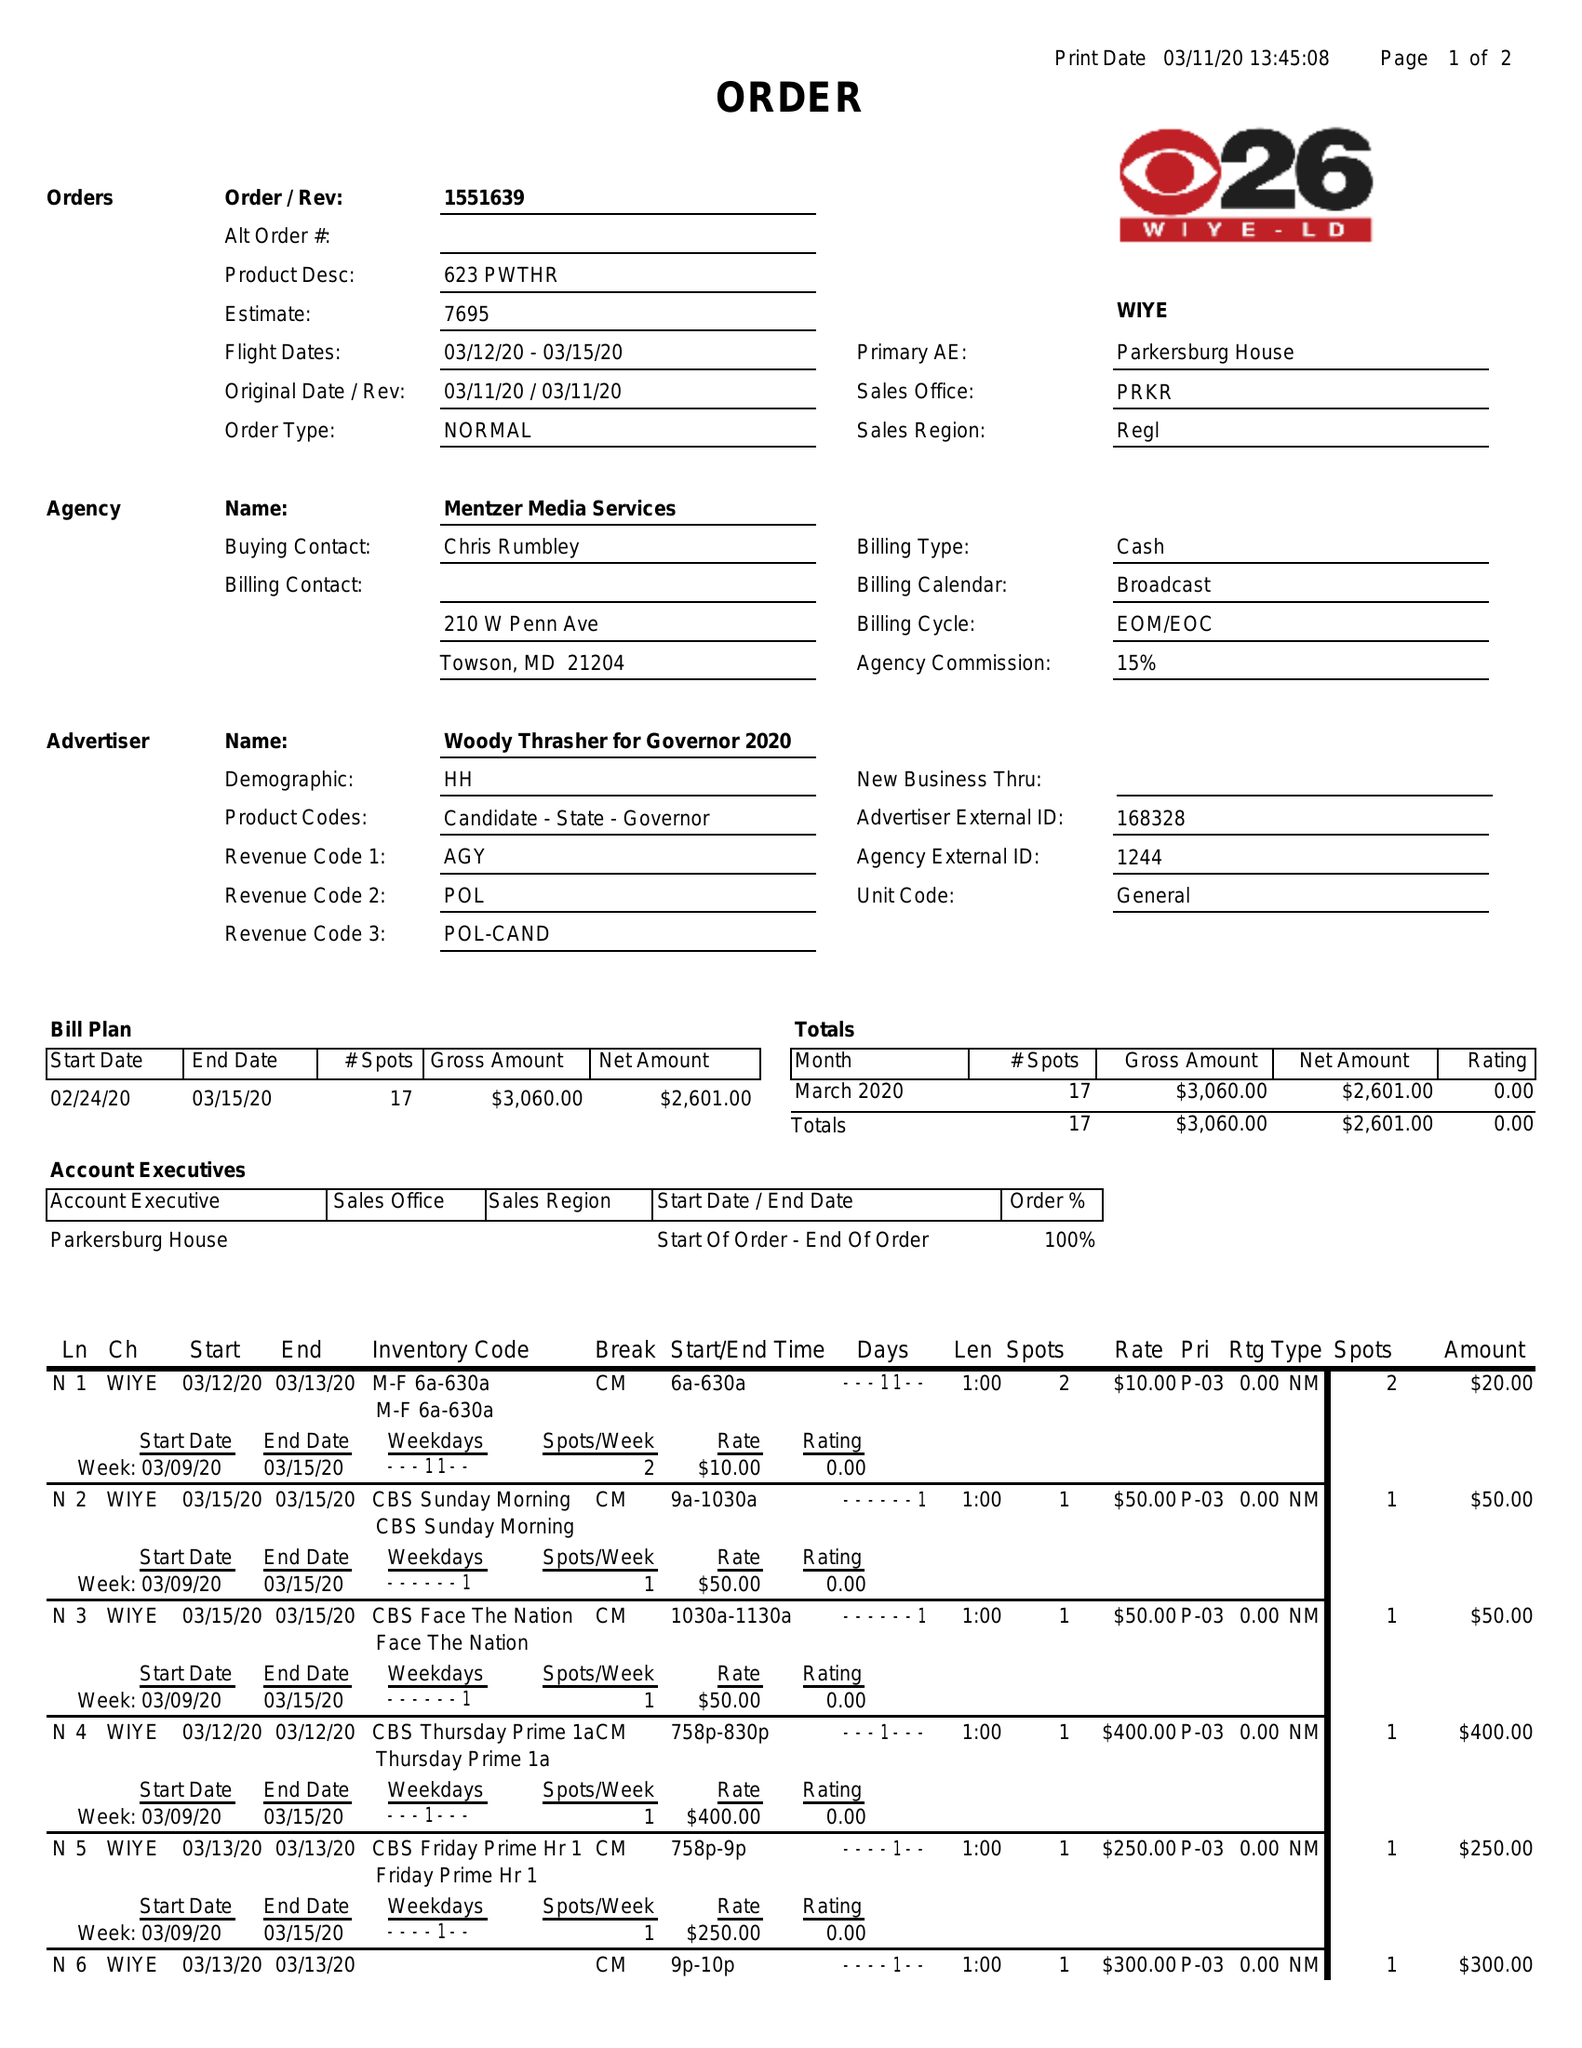What is the value for the flight_from?
Answer the question using a single word or phrase. 03/12/20 